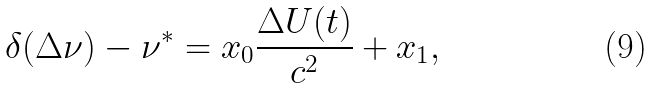Convert formula to latex. <formula><loc_0><loc_0><loc_500><loc_500>\delta ( \Delta \nu ) - \nu ^ { * } = x _ { 0 } \frac { \Delta U ( t ) } { c ^ { 2 } } + x _ { 1 } ,</formula> 